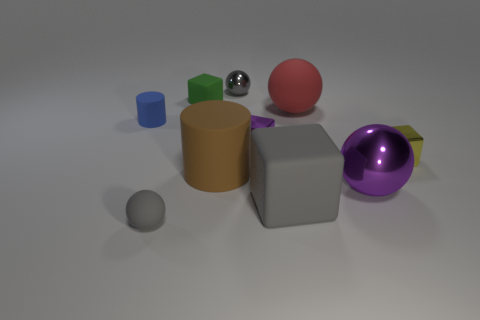Subtract all yellow blocks. How many blocks are left? 3 Subtract all purple cubes. How many cubes are left? 3 Subtract 0 cyan balls. How many objects are left? 10 Subtract all spheres. How many objects are left? 6 Subtract 4 spheres. How many spheres are left? 0 Subtract all purple spheres. Subtract all yellow cylinders. How many spheres are left? 3 Subtract all purple cylinders. How many yellow balls are left? 0 Subtract all purple blocks. Subtract all gray blocks. How many objects are left? 8 Add 2 tiny spheres. How many tiny spheres are left? 4 Add 9 big rubber cubes. How many big rubber cubes exist? 10 